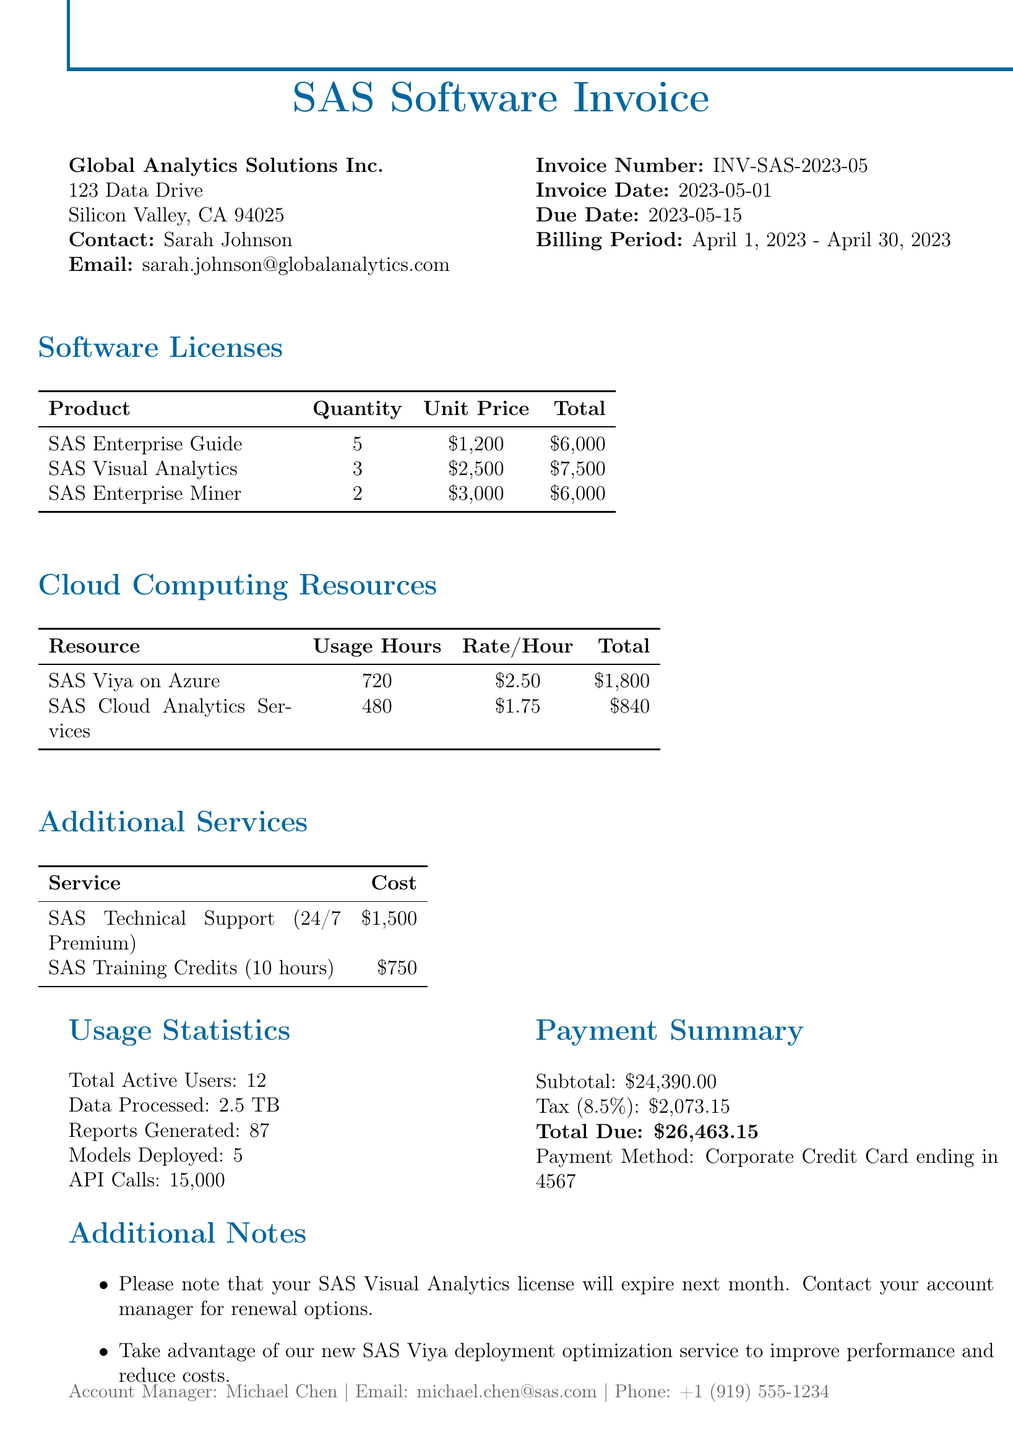What is the invoice number? The invoice number is clearly stated in the invoice details section, which is INV-SAS-2023-05.
Answer: INV-SAS-2023-05 What is the total due amount? The total due amount is provided in the payment summary section, which states the total due is $26,463.15.
Answer: $26,463.15 Who is the contact person for the client? The contact person is specified in the client information section, which lists Sarah Johnson.
Answer: Sarah Johnson How many licenses of SAS Visual Analytics are there? The quantity of SAS Visual Analytics licenses is indicated in the software licenses section, which is 3.
Answer: 3 What is the total cost for SAS Viya on Azure? The total cost for SAS Viya on Azure is provided in the cloud computing resources section, which states it is $1,800.
Answer: $1,800 What is the tax rate applied to the invoice? The tax rate is mentioned in the payment summary section, which is 8.5%.
Answer: 8.5% How many total active users are mentioned? The total active users statistic is listed in usage statistics, which states there are 12 active users.
Answer: 12 What additional service has a cost of $750? The additional service with a cost of $750 is listed in the additional services section, specifying it as SAS Training Credits.
Answer: SAS Training Credits What is the billing period for this invoice? The billing period is clearly defined in the invoice details section, which is April 1, 2023 - April 30, 2023.
Answer: April 1, 2023 - April 30, 2023 